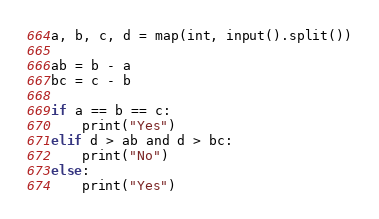Convert code to text. <code><loc_0><loc_0><loc_500><loc_500><_Python_>a, b, c, d = map(int, input().split())

ab = b - a
bc = c - b

if a == b == c:
    print("Yes")
elif d > ab and d > bc:
    print("No")
else:
    print("Yes")</code> 